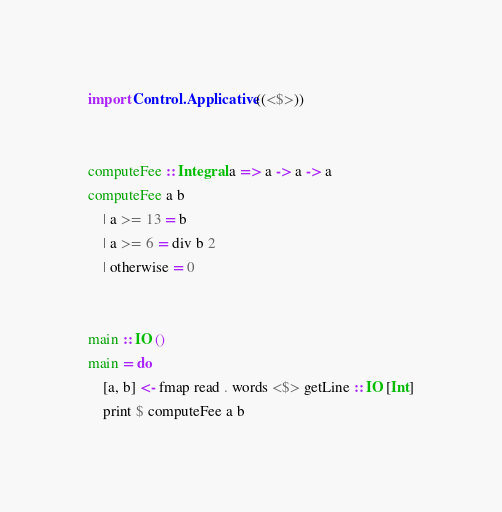<code> <loc_0><loc_0><loc_500><loc_500><_Haskell_>import Control.Applicative ((<$>))


computeFee :: Integral a => a -> a -> a
computeFee a b
    | a >= 13 = b
    | a >= 6 = div b 2
    | otherwise = 0


main :: IO ()
main = do
    [a, b] <- fmap read . words <$> getLine :: IO [Int]
    print $ computeFee a b
</code> 